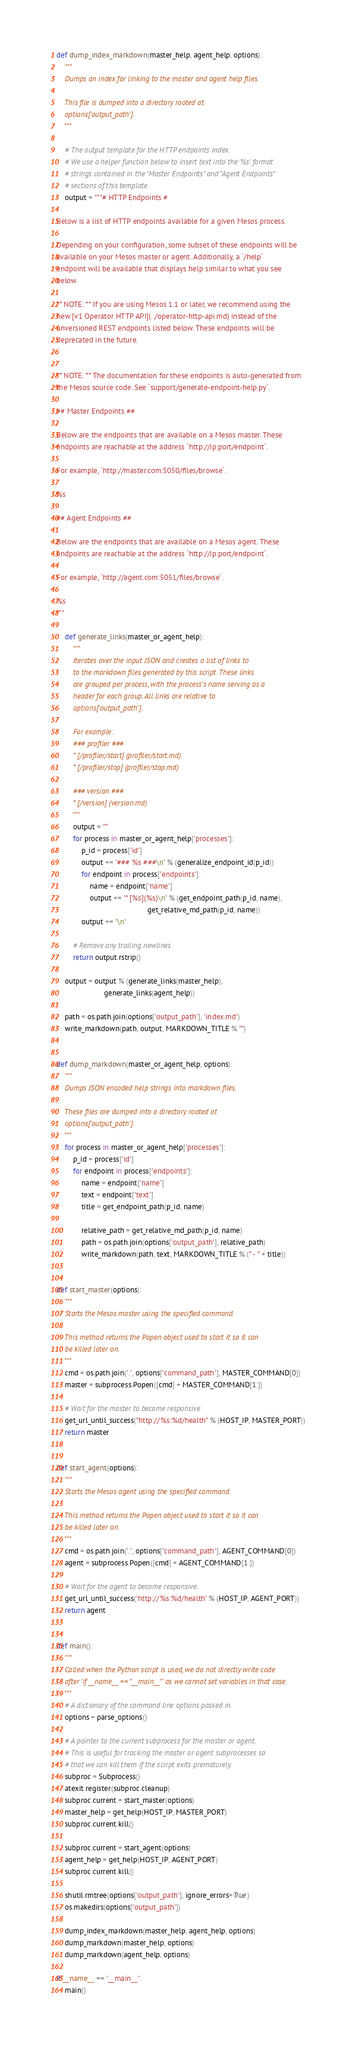<code> <loc_0><loc_0><loc_500><loc_500><_Python_>
def dump_index_markdown(master_help, agent_help, options):
    """
    Dumps an index for linking to the master and agent help files.

    This file is dumped into a directory rooted at
    options['output_path'].
    """

    # The output template for the HTTP endpoints index.
    # We use a helper function below to insert text into the '%s' format
    # strings contained in the "Master Endpoints" and "Agent Endpoints"
    # sections of this template.
    output = """# HTTP Endpoints #

Below is a list of HTTP endpoints available for a given Mesos process.

Depending on your configuration, some subset of these endpoints will be
available on your Mesos master or agent. Additionally, a `/help`
endpoint will be available that displays help similar to what you see
below.

** NOTE: ** If you are using Mesos 1.1 or later, we recommend using the
new [v1 Operator HTTP API](../operator-http-api.md) instead of the
unversioned REST endpoints listed below. These endpoints will be
deprecated in the future.


** NOTE: ** The documentation for these endpoints is auto-generated from
the Mesos source code. See `support/generate-endpoint-help.py`.

## Master Endpoints ##

Below are the endpoints that are available on a Mesos master. These
endpoints are reachable at the address `http://ip:port/endpoint`.

For example, `http://master.com:5050/files/browse`.

%s

## Agent Endpoints ##

Below are the endpoints that are available on a Mesos agent. These
endpoints are reachable at the address `http://ip:port/endpoint`.

For example, `http://agent.com:5051/files/browse`.

%s
"""

    def generate_links(master_or_agent_help):
        """
        Iterates over the input JSON and creates a list of links to
        to the markdown files generated by this script. These links
        are grouped per process, with the process's name serving as a
        header for each group. All links are relative to
        options['output_path'].

        For example:
        ### profiler ###
        * [/profiler/start] (profiler/start.md)
        * [/profiler/stop] (profiler/stop.md)

        ### version ###
        * [/version] (version.md)
        """
        output = ""
        for process in master_or_agent_help['processes']:
            p_id = process['id']
            output += '### %s ###\n' % (generalize_endpoint_id(p_id))
            for endpoint in process['endpoints']:
                name = endpoint['name']
                output += '* [%s](%s)\n' % (get_endpoint_path(p_id, name),
                                            get_relative_md_path(p_id, name))
            output += '\n'

        # Remove any trailing newlines
        return output.rstrip()

    output = output % (generate_links(master_help),
                       generate_links(agent_help))

    path = os.path.join(options['output_path'], 'index.md')
    write_markdown(path, output, MARKDOWN_TITLE % "")


def dump_markdown(master_or_agent_help, options):
    """
    Dumps JSON encoded help strings into markdown files.

    These files are dumped into a directory rooted at
    options['output_path'].
    """
    for process in master_or_agent_help['processes']:
        p_id = process['id']
        for endpoint in process['endpoints']:
            name = endpoint['name']
            text = endpoint['text']
            title = get_endpoint_path(p_id, name)

            relative_path = get_relative_md_path(p_id, name)
            path = os.path.join(options['output_path'], relative_path)
            write_markdown(path, text, MARKDOWN_TITLE % (" - " + title))


def start_master(options):
    """
    Starts the Mesos master using the specified command.

    This method returns the Popen object used to start it so it can
    be killed later on.
    """
    cmd = os.path.join('.', options['command_path'], MASTER_COMMAND[0])
    master = subprocess.Popen([cmd] + MASTER_COMMAND[1:])

    # Wait for the master to become responsive
    get_url_until_success("http://%s:%d/health" % (HOST_IP, MASTER_PORT))
    return master


def start_agent(options):
    """
    Starts the Mesos agent using the specified command.

    This method returns the Popen object used to start it so it can
    be killed later on.
    """
    cmd = os.path.join('.', options['command_path'], AGENT_COMMAND[0])
    agent = subprocess.Popen([cmd] + AGENT_COMMAND[1:])

    # Wait for the agent to become responsive.
    get_url_until_success('http://%s:%d/health' % (HOST_IP, AGENT_PORT))
    return agent


def main():
    """
    Called when the Python script is used, we do not directly write code
    after 'if __name__ == "__main__"' as we cannot set variables in that case.
    """
    # A dictionary of the command line options passed in.
    options = parse_options()

    # A pointer to the current subprocess for the master or agent.
    # This is useful for tracking the master or agent subprocesses so
    # that we can kill them if the script exits prematurely.
    subproc = Subprocess()
    atexit.register(subproc.cleanup)
    subproc.current = start_master(options)
    master_help = get_help(HOST_IP, MASTER_PORT)
    subproc.current.kill()

    subproc.current = start_agent(options)
    agent_help = get_help(HOST_IP, AGENT_PORT)
    subproc.current.kill()

    shutil.rmtree(options['output_path'], ignore_errors=True)
    os.makedirs(options['output_path'])

    dump_index_markdown(master_help, agent_help, options)
    dump_markdown(master_help, options)
    dump_markdown(agent_help, options)

if __name__ == '__main__':
    main()
</code> 